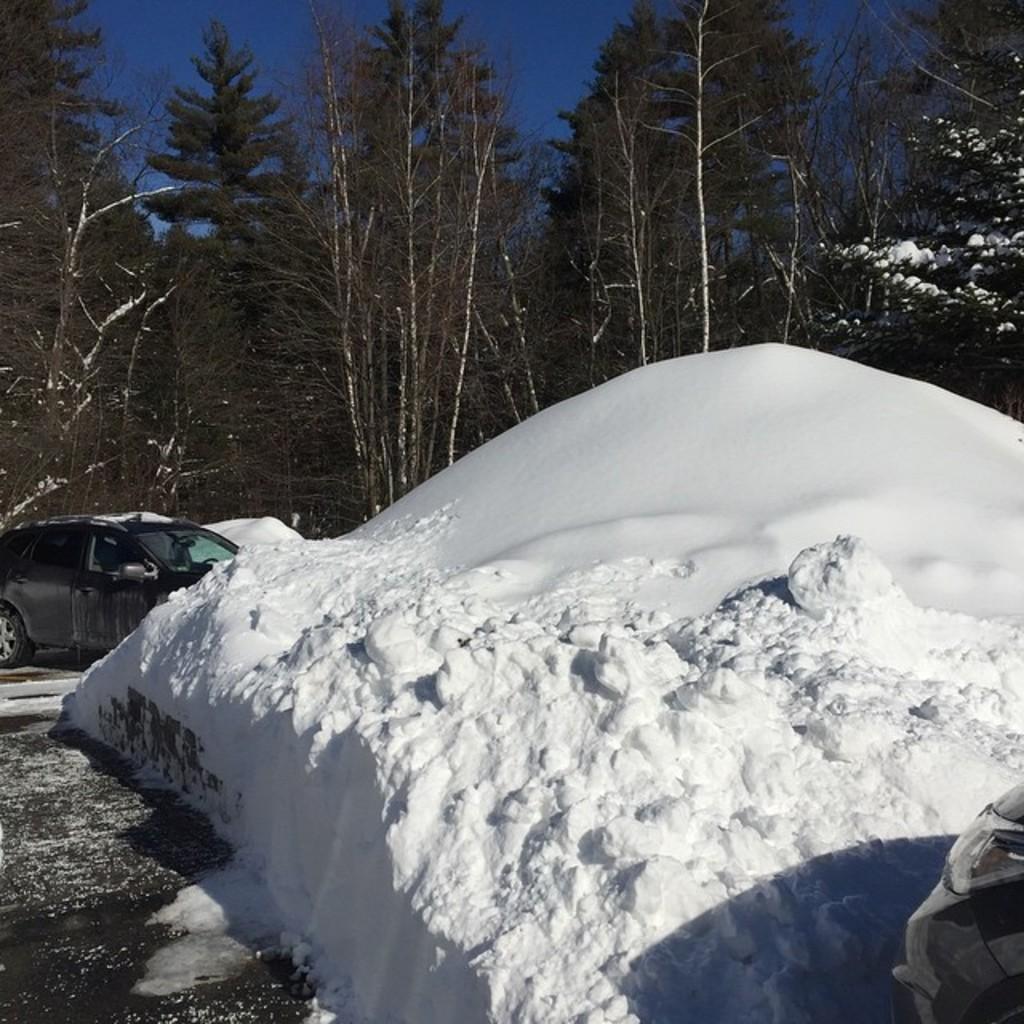Describe this image in one or two sentences. In the picture we can see a snow hill which is on the path and beside it, we can see a car which is black in color and behind it we can see trees and sky. 